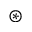Convert formula to latex. <formula><loc_0><loc_0><loc_500><loc_500>\circledast</formula> 